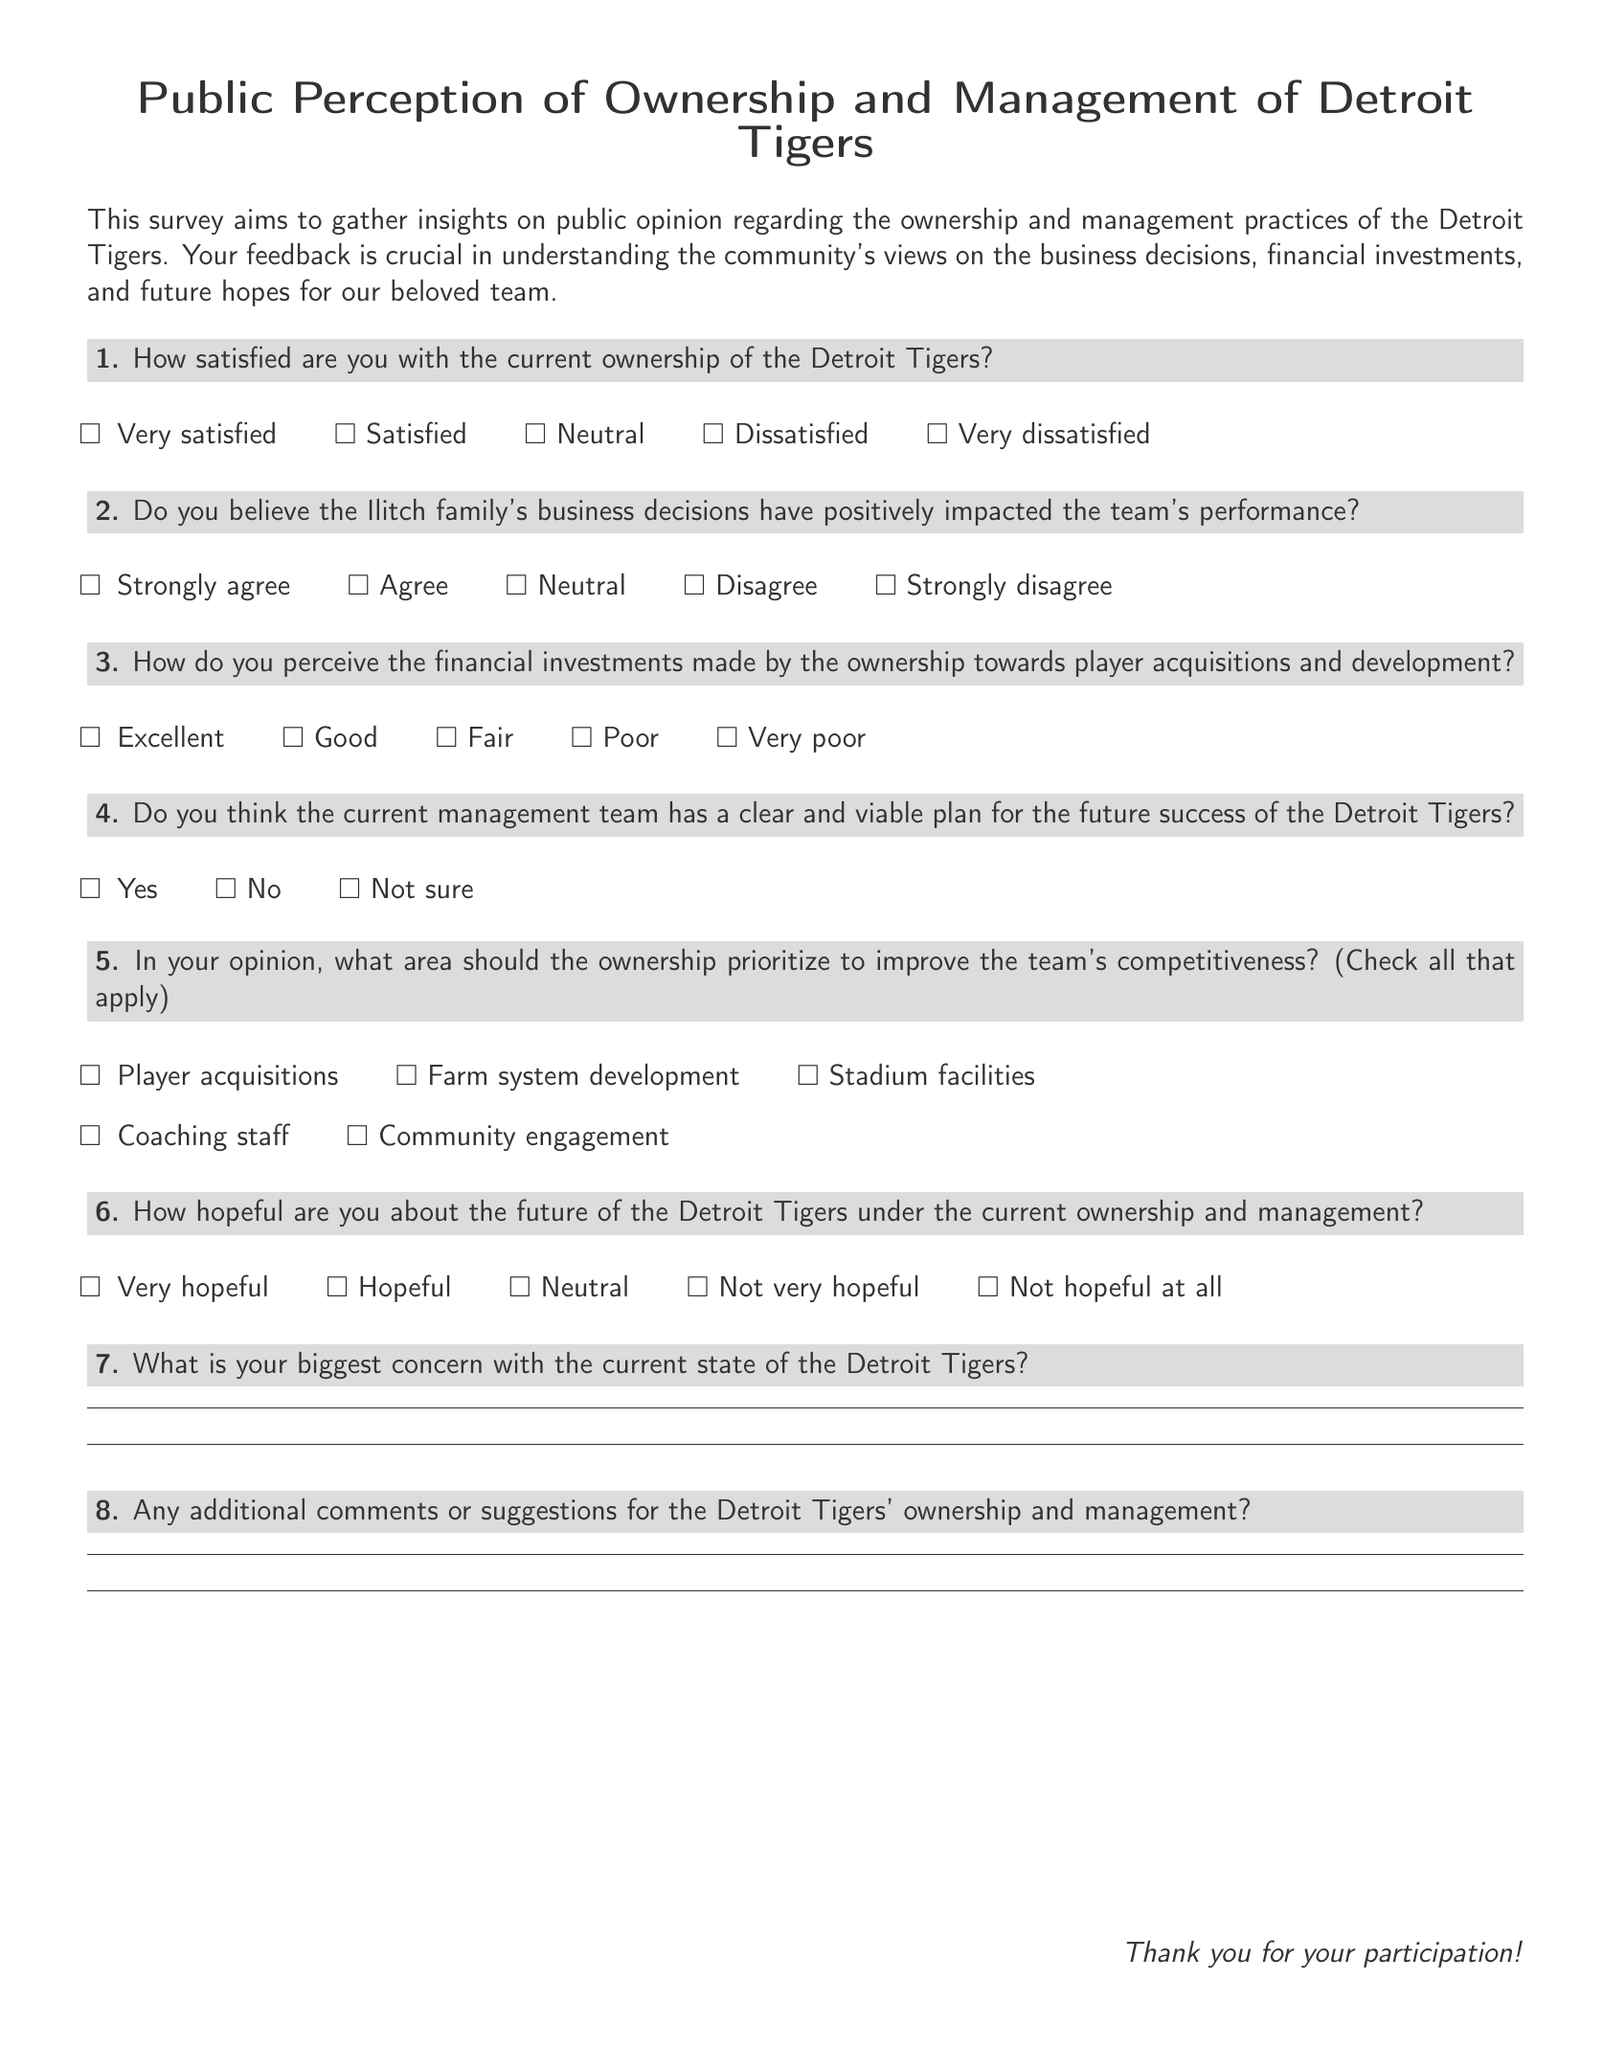How many total questions are in the survey? The survey contains a total of eight questions, numbered one through eight.
Answer: 8 What is the first question about? The first question asks about the satisfaction level with the current ownership of the Detroit Tigers.
Answer: Satisfaction with ownership What options are provided for the fourth question? The options for the fourth question regarding the management team's future success are "Yes," "No," and "Not sure."
Answer: Yes, No, Not sure What area does the survey suggest ownership should prioritize? The survey suggests several areas, including "Player acquisitions," "Farm system development," "Stadium facilities," "Coaching staff," and "Community engagement."
Answer: Player acquisitions, Farm system development, Stadium facilities, Coaching staff, Community engagement How is the survey structured in terms of feedback? The survey allows for both multiple-choice answers and open-ended responses for concerns and suggestions.
Answer: Multiple-choice and open-ended responses 